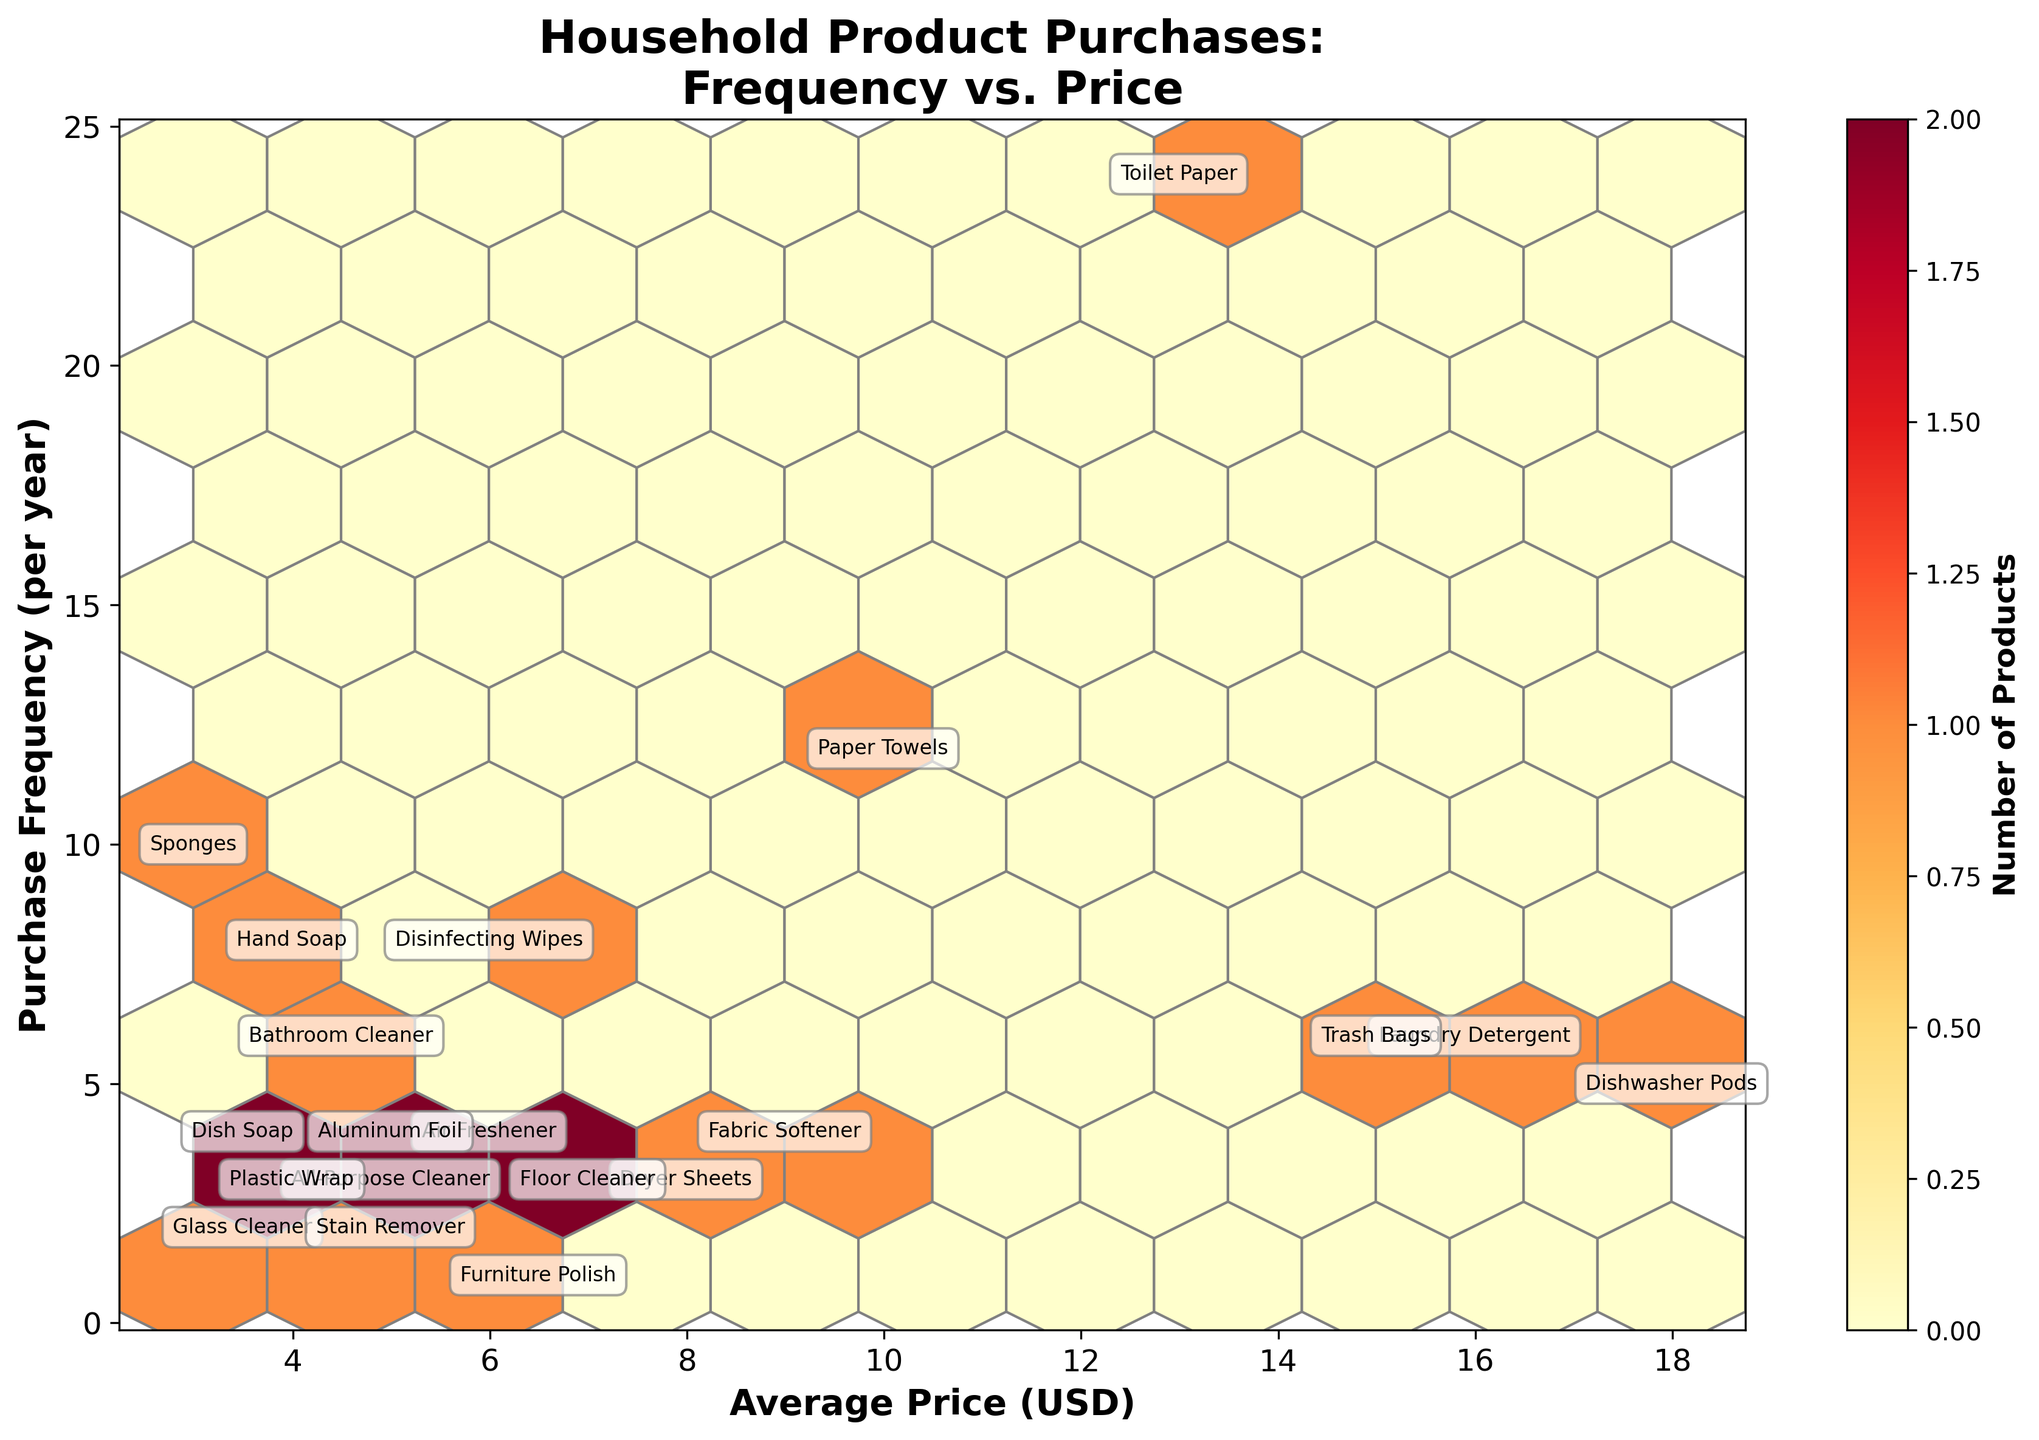What is the title of the figure? The title is usually displayed prominently at the top of a figure. In this case, it is displayed in a larger and bold font.
Answer: Household Product Purchases: Frequency vs. Price How many products are purchased more than 10 times per year? To determine this, look at the y-axis and count the categories with a purchase frequency greater than 10.
Answer: 2 products Which product appears at the highest average price? Locate the highest value on the x-axis, which represents the average price, and identify the annotated product name closest to this value.
Answer: Dishwasher Pods Is there a product with a frequency of purchase of exactly 3 times per year and an average price below $5? Check the plotted points where y = 3 and x < 5, then read the label of the matching point.
Answer: All-Purpose Cleaner What is the range of the average price for the products on the plot? Identify the minimum and maximum values on the x-axis by observing the range covered by the plotted hexagons.
Answer: $2.99 to $17.99 How many products fall into the price range between $4 and $8? Count the products whose average price falls within the $4 to $8 range according to the x-axis.
Answer: 8 products Which has a higher purchase frequency, Fabric Softener or Aluminum Foil? Look at the y-values next to the annotations for Fabric Softener and Aluminum Foil and compare them.
Answer: Aluminum Foil What is the overall trend observed between price and purchase frequency? Observe the density and distribution of hexagons on the plot; a trend is indicated by the concentration and spread of hexagon bins.
Answer: Products with lower prices tend to be purchased more frequently Which product is purchased less than 4 times per year and costs more than $5 on average? Locate points with a frequency less than 4 and an average price greater than $5, then read the corresponding annotation.
Answer: Furniture Polish 